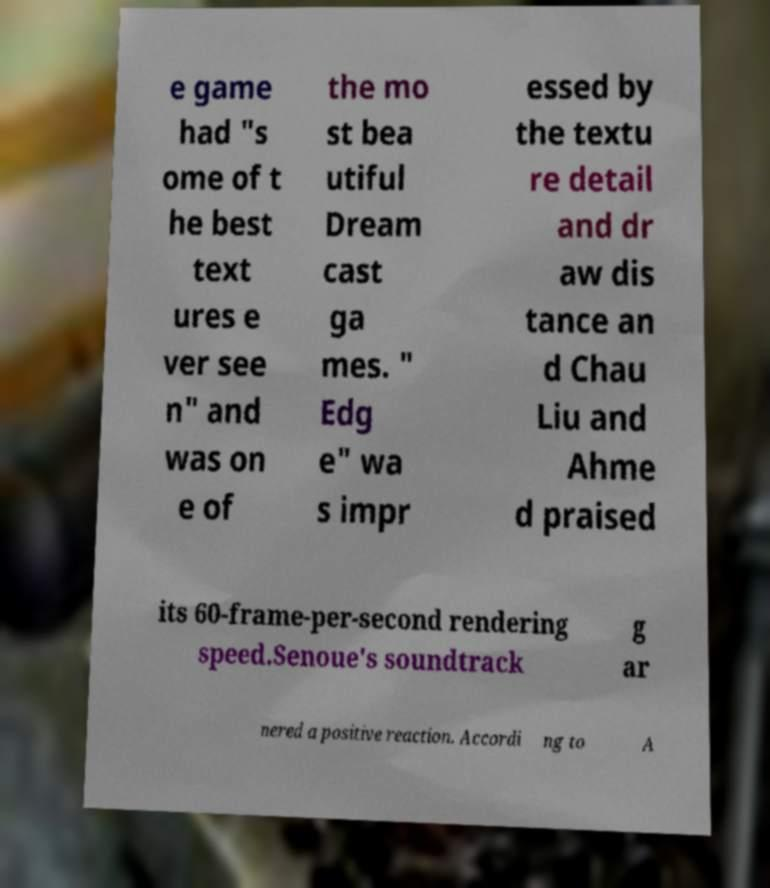Could you assist in decoding the text presented in this image and type it out clearly? e game had "s ome of t he best text ures e ver see n" and was on e of the mo st bea utiful Dream cast ga mes. " Edg e" wa s impr essed by the textu re detail and dr aw dis tance an d Chau Liu and Ahme d praised its 60-frame-per-second rendering speed.Senoue's soundtrack g ar nered a positive reaction. Accordi ng to A 